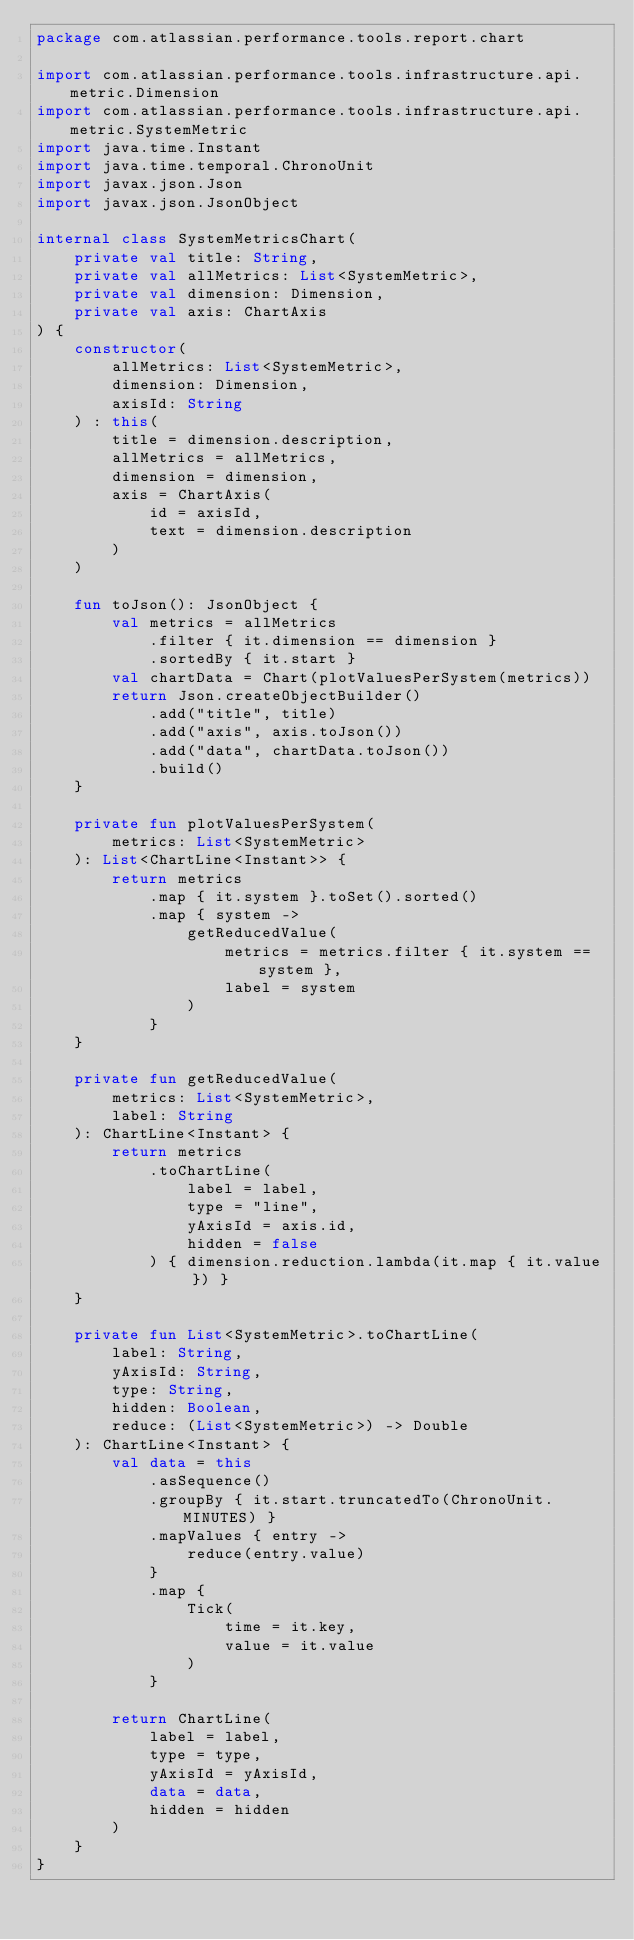<code> <loc_0><loc_0><loc_500><loc_500><_Kotlin_>package com.atlassian.performance.tools.report.chart

import com.atlassian.performance.tools.infrastructure.api.metric.Dimension
import com.atlassian.performance.tools.infrastructure.api.metric.SystemMetric
import java.time.Instant
import java.time.temporal.ChronoUnit
import javax.json.Json
import javax.json.JsonObject

internal class SystemMetricsChart(
    private val title: String,
    private val allMetrics: List<SystemMetric>,
    private val dimension: Dimension,
    private val axis: ChartAxis
) {
    constructor(
        allMetrics: List<SystemMetric>,
        dimension: Dimension,
        axisId: String
    ) : this(
        title = dimension.description,
        allMetrics = allMetrics,
        dimension = dimension,
        axis = ChartAxis(
            id = axisId,
            text = dimension.description
        )
    )

    fun toJson(): JsonObject {
        val metrics = allMetrics
            .filter { it.dimension == dimension }
            .sortedBy { it.start }
        val chartData = Chart(plotValuesPerSystem(metrics))
        return Json.createObjectBuilder()
            .add("title", title)
            .add("axis", axis.toJson())
            .add("data", chartData.toJson())
            .build()
    }

    private fun plotValuesPerSystem(
        metrics: List<SystemMetric>
    ): List<ChartLine<Instant>> {
        return metrics
            .map { it.system }.toSet().sorted()
            .map { system ->
                getReducedValue(
                    metrics = metrics.filter { it.system == system },
                    label = system
                )
            }
    }

    private fun getReducedValue(
        metrics: List<SystemMetric>,
        label: String
    ): ChartLine<Instant> {
        return metrics
            .toChartLine(
                label = label,
                type = "line",
                yAxisId = axis.id,
                hidden = false
            ) { dimension.reduction.lambda(it.map { it.value }) }
    }

    private fun List<SystemMetric>.toChartLine(
        label: String,
        yAxisId: String,
        type: String,
        hidden: Boolean,
        reduce: (List<SystemMetric>) -> Double
    ): ChartLine<Instant> {
        val data = this
            .asSequence()
            .groupBy { it.start.truncatedTo(ChronoUnit.MINUTES) }
            .mapValues { entry ->
                reduce(entry.value)
            }
            .map {
                Tick(
                    time = it.key,
                    value = it.value
                )
            }

        return ChartLine(
            label = label,
            type = type,
            yAxisId = yAxisId,
            data = data,
            hidden = hidden
        )
    }
}</code> 